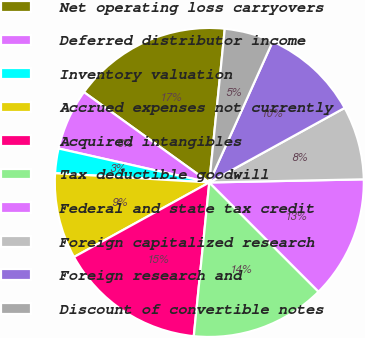<chart> <loc_0><loc_0><loc_500><loc_500><pie_chart><fcel>Net operating loss carryovers<fcel>Deferred distributor income<fcel>Inventory valuation<fcel>Accrued expenses not currently<fcel>Acquired intangibles<fcel>Tax deductible goodwill<fcel>Federal and state tax credit<fcel>Foreign capitalized research<fcel>Foreign research and<fcel>Discount of convertible notes<nl><fcel>16.66%<fcel>6.41%<fcel>2.57%<fcel>8.97%<fcel>15.38%<fcel>14.1%<fcel>12.82%<fcel>7.69%<fcel>10.26%<fcel>5.13%<nl></chart> 